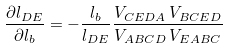<formula> <loc_0><loc_0><loc_500><loc_500>\frac { \partial l _ { D E } } { \partial l _ { b } } = - \frac { l _ { b } } { l _ { D E } } \frac { V _ { C E D A } \, V _ { B C E D } } { V _ { A B C D } \, V _ { E A B C } }</formula> 